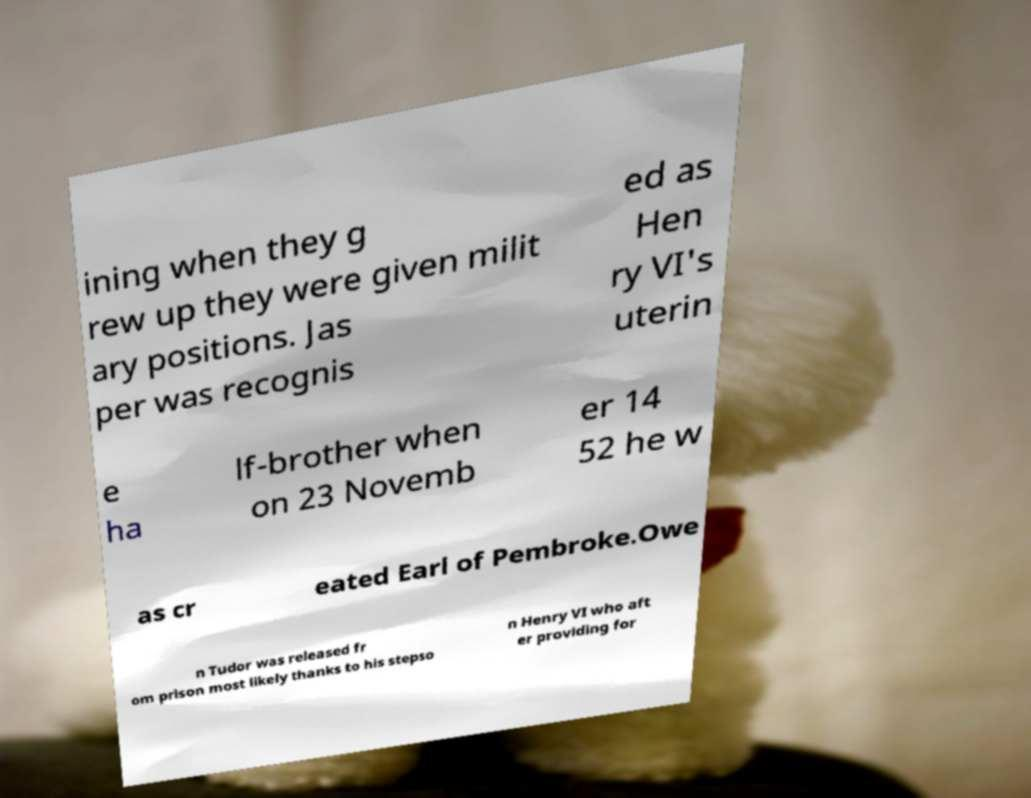Can you accurately transcribe the text from the provided image for me? ining when they g rew up they were given milit ary positions. Jas per was recognis ed as Hen ry VI's uterin e ha lf-brother when on 23 Novemb er 14 52 he w as cr eated Earl of Pembroke.Owe n Tudor was released fr om prison most likely thanks to his stepso n Henry VI who aft er providing for 